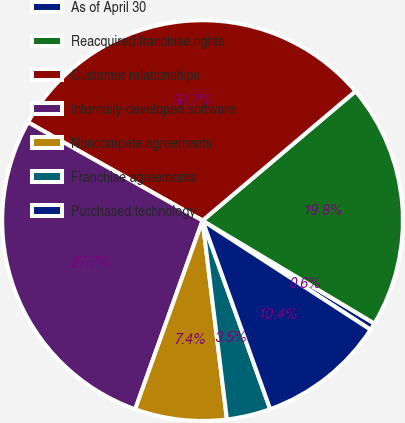Convert chart. <chart><loc_0><loc_0><loc_500><loc_500><pie_chart><fcel>As of April 30<fcel>Reacquired franchise rights<fcel>Customer relationships<fcel>Internally-developed software<fcel>Noncompete agreements<fcel>Franchise agreements<fcel>Purchased technology<nl><fcel>0.58%<fcel>19.76%<fcel>30.66%<fcel>27.71%<fcel>7.4%<fcel>3.54%<fcel>10.35%<nl></chart> 